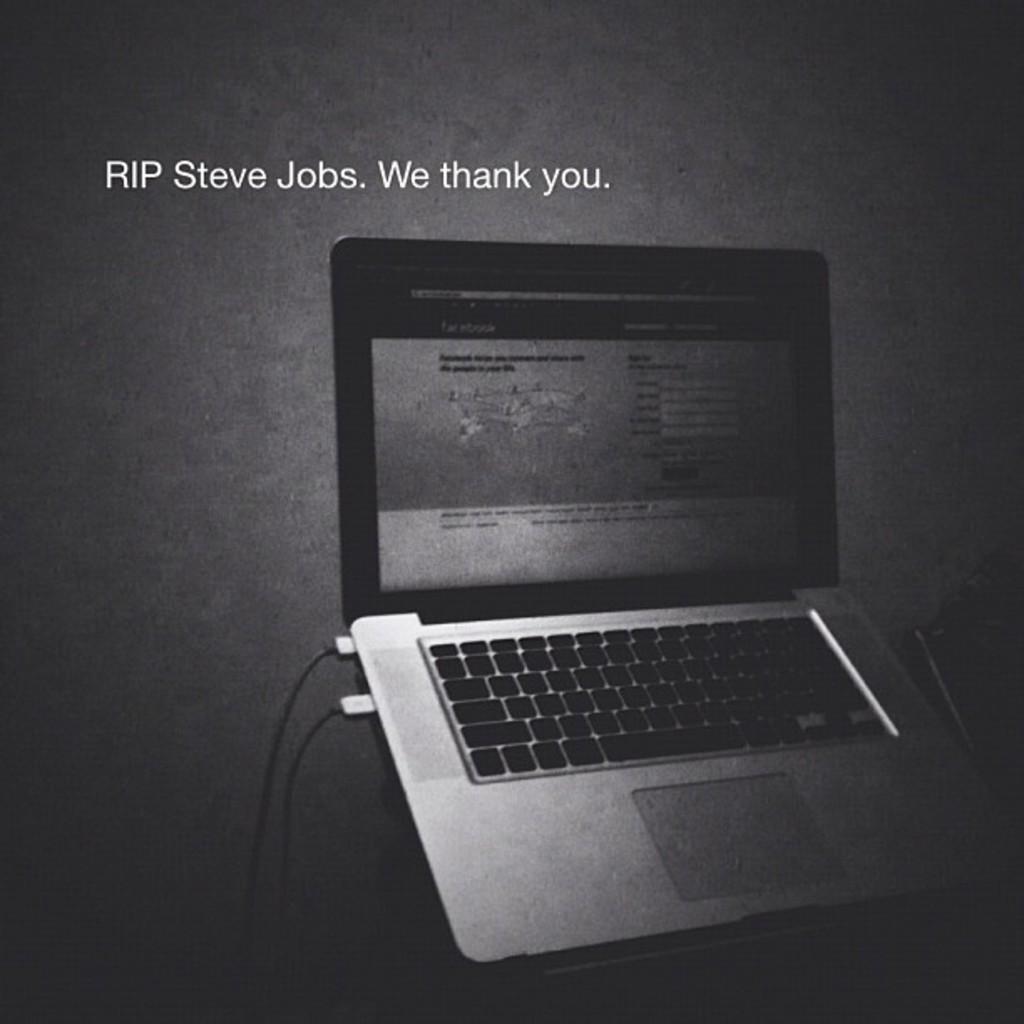Whos is this picture honoring?
Ensure brevity in your answer.  Steve jobs. Who is the name of the ceo the picture is referring to?
Your response must be concise. Steve jobs. 